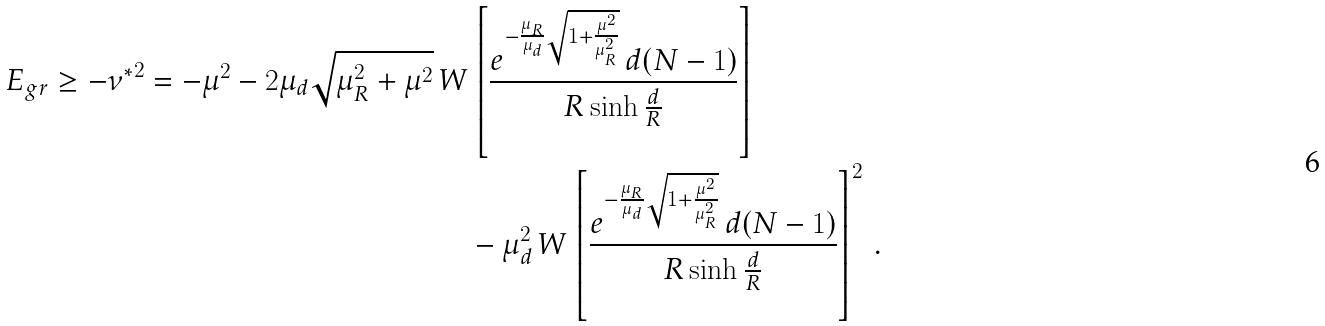Convert formula to latex. <formula><loc_0><loc_0><loc_500><loc_500>E _ { g r } \geq - { \nu ^ { * } } ^ { 2 } = - \mu ^ { 2 } - 2 \mu _ { d } \sqrt { \mu _ { R } ^ { 2 } + \mu ^ { 2 } } \, & W \left [ \frac { e ^ { - \frac { \mu _ { R } } { \mu _ { d } } \sqrt { 1 + \frac { \mu ^ { 2 } } { \mu _ { R } ^ { 2 } } } } \, d ( N - 1 ) } { R \sinh \frac { d } { R } } \right ] \\ & \quad - \mu _ { d } ^ { 2 } \, W \left [ \frac { e ^ { - \frac { \mu _ { R } } { \mu _ { d } } \sqrt { 1 + \frac { \mu ^ { 2 } } { \mu _ { R } ^ { 2 } } } } \, d ( N - 1 ) } { R \sinh \frac { d } { R } } \right ] ^ { 2 } \, .</formula> 